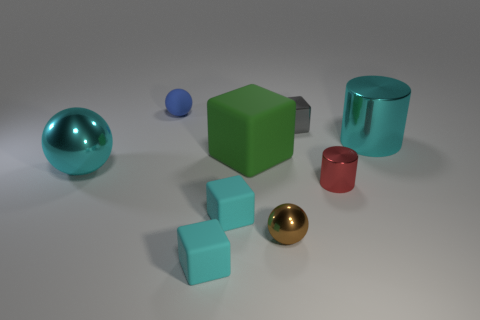Is there a blue rubber ball that has the same size as the brown ball?
Provide a short and direct response. Yes. There is another metallic thing that is the same shape as the big green thing; what color is it?
Your answer should be very brief. Gray. There is a big cyan metal thing that is left of the big block; are there any tiny spheres behind it?
Offer a terse response. Yes. Does the big cyan shiny thing left of the small red cylinder have the same shape as the brown object?
Your response must be concise. Yes. The small blue matte object is what shape?
Provide a short and direct response. Sphere. What number of small yellow blocks are made of the same material as the large cyan sphere?
Provide a succinct answer. 0. There is a large cylinder; does it have the same color as the metallic object that is behind the cyan cylinder?
Make the answer very short. No. How many large cyan metal spheres are there?
Ensure brevity in your answer.  1. Are there any large matte objects that have the same color as the tiny metal ball?
Your answer should be very brief. No. There is a big metallic thing behind the large metallic object to the left of the tiny metallic object that is behind the red cylinder; what is its color?
Provide a succinct answer. Cyan. 